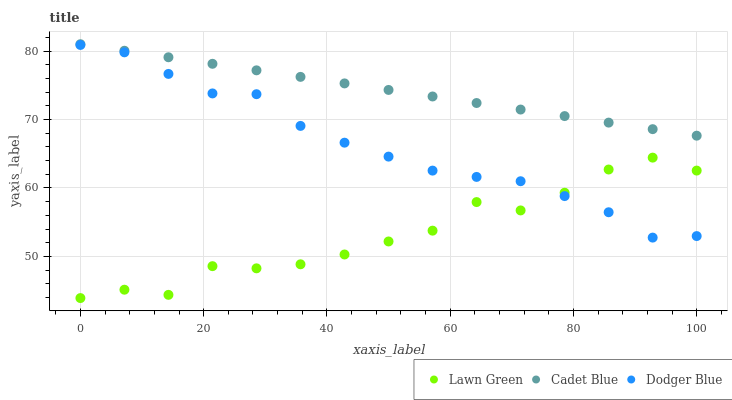Does Lawn Green have the minimum area under the curve?
Answer yes or no. Yes. Does Cadet Blue have the maximum area under the curve?
Answer yes or no. Yes. Does Dodger Blue have the minimum area under the curve?
Answer yes or no. No. Does Dodger Blue have the maximum area under the curve?
Answer yes or no. No. Is Cadet Blue the smoothest?
Answer yes or no. Yes. Is Lawn Green the roughest?
Answer yes or no. Yes. Is Dodger Blue the smoothest?
Answer yes or no. No. Is Dodger Blue the roughest?
Answer yes or no. No. Does Lawn Green have the lowest value?
Answer yes or no. Yes. Does Dodger Blue have the lowest value?
Answer yes or no. No. Does Cadet Blue have the highest value?
Answer yes or no. Yes. Does Dodger Blue have the highest value?
Answer yes or no. No. Is Dodger Blue less than Cadet Blue?
Answer yes or no. Yes. Is Cadet Blue greater than Lawn Green?
Answer yes or no. Yes. Does Dodger Blue intersect Lawn Green?
Answer yes or no. Yes. Is Dodger Blue less than Lawn Green?
Answer yes or no. No. Is Dodger Blue greater than Lawn Green?
Answer yes or no. No. Does Dodger Blue intersect Cadet Blue?
Answer yes or no. No. 